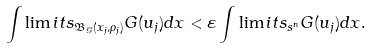<formula> <loc_0><loc_0><loc_500><loc_500>\int \lim i t s _ { \mathfrak B _ { \mathcal { G } } ( x _ { j } , \rho _ { j } ) } G ( u _ { j } ) d x < \varepsilon \int \lim i t s _ { \real s ^ { n } } G ( u _ { j } ) d x .</formula> 